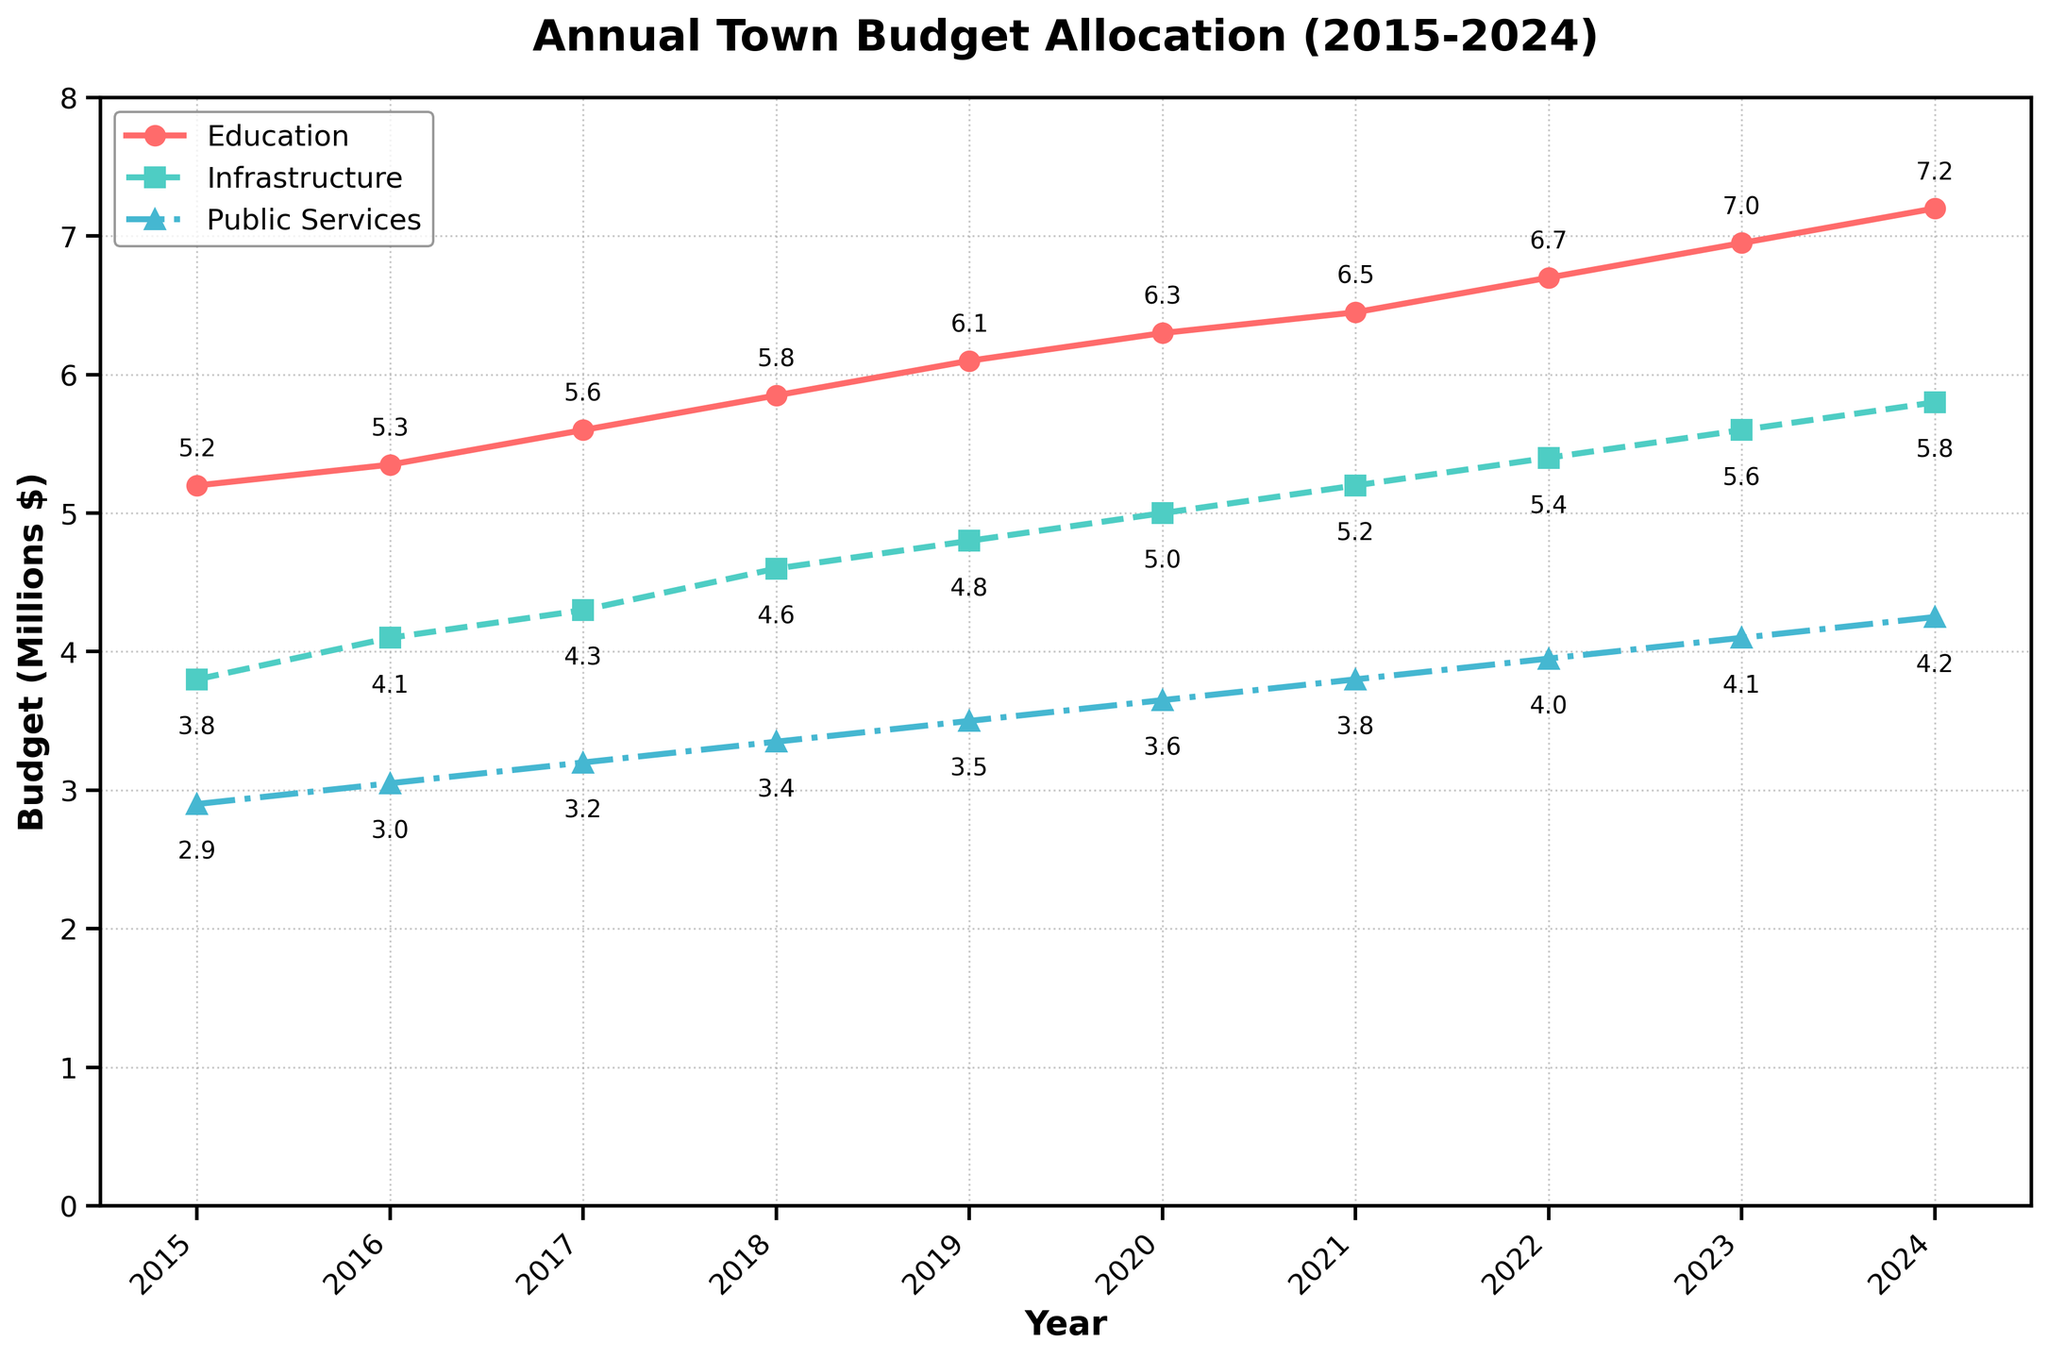What was the Education budget in 2018? The figure shows the education budget for each year. Find 2018 on the x-axis and read the corresponding value on the education line, which is marked with circles. The value is 5.85 million dollars
Answer: 5.85 million dollars What is the difference between the Infrastructure and Public Services budgets in 2023? Locate 2023 on the x-axis and find the values for both Infrastructure (marked with squares) and Public Services (marked with triangles). Subtract the Public Services budget from the Infrastructure budget: 5.6 million - 4.1 million = 1.5 million dollars
Answer: 1.5 million dollars By how much did the Education budget increase from 2015 to 2024? Find the Education budget values for 2015 and 2024 on the chart. Subtract the 2015 value from the 2024 value: 7.2 million - 5.2 million = 2 million dollars
Answer: 2 million dollars In which year were all three budgets equally spaced apart? Look for a year where the differences between the three budgets are approximately equal to each other. In 2015, the differences are close: (5.2 million - 3.8 million) ≈ (3.8 million - 2.9 million) ≈ 1.4 million dollars
Answer: 2015 Which budget saw the highest overall increase from 2015 to 2024? Compare the increase in each budget from 2015 to 2024. Education: 7.2 million - 5.2 million = 2 million dollars, Infrastructure: 5.8 million - 3.8 million = 2 million dollars, Public Services: 4.25 million - 2.9 million ≈ 1.35 million dollars. Both Education and Infrastructure saw the highest increase of 2 million dollars
Answer: Education and Infrastructure How many years from 2015 to 2024 did the Public Services budget surpass 4 million dollars? Identify the years where the Public Services budget was greater than 4 million dollars by looking at the line marked with triangles. The budget surpassed 4 million dollars in 2023 and 2024.
Answer: 2 years Is there any year where the Education budget was exactly double the Public Services budget? If so, which year? Find the years where the value for Public Services is half of the value for Education. In 2018, Education (5.85 million) is not exactly double Public Services (3.35 million), neither are other years.
Answer: No year What trend can be observed in the Infrastructure budget over the years 2015 to 2024? Observe the trajectory of the line marked with squares. The Infrastructure budget shows a continuous and steady increase each year from 3.8 million in 2015 to 5.8 million in 2024.
Answer: Steady increase Between which two consecutive years was the highest increase in the Public Services budget observed? Compare year-to-year increases by looking at the values for Public Services. The largest increase is between 2022 (3.95 million) and 2023 (4.1 million), which is an increase of 0.15 million dollars.
Answer: Between 2022 and 2023 